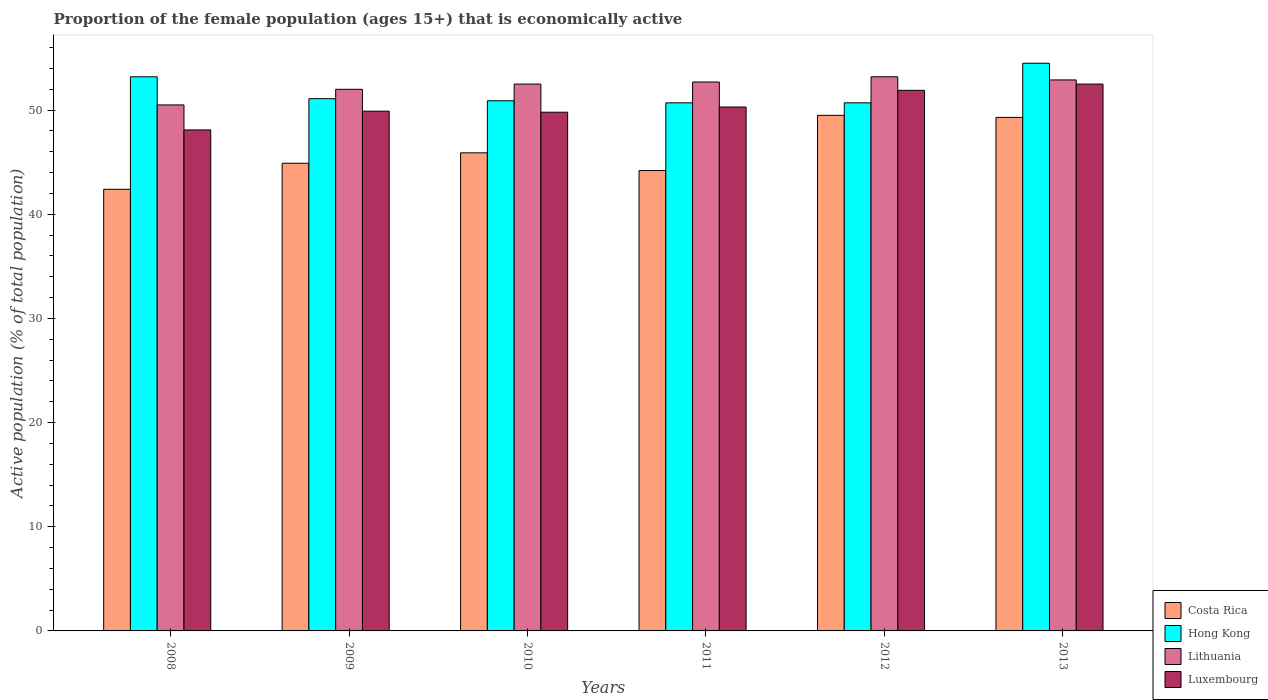How many different coloured bars are there?
Provide a succinct answer. 4. Are the number of bars per tick equal to the number of legend labels?
Your answer should be very brief. Yes. Are the number of bars on each tick of the X-axis equal?
Offer a terse response. Yes. How many bars are there on the 2nd tick from the left?
Your response must be concise. 4. How many bars are there on the 1st tick from the right?
Offer a very short reply. 4. What is the label of the 5th group of bars from the left?
Offer a terse response. 2012. In how many cases, is the number of bars for a given year not equal to the number of legend labels?
Offer a very short reply. 0. What is the proportion of the female population that is economically active in Luxembourg in 2009?
Keep it short and to the point. 49.9. Across all years, what is the maximum proportion of the female population that is economically active in Lithuania?
Provide a succinct answer. 53.2. Across all years, what is the minimum proportion of the female population that is economically active in Costa Rica?
Your answer should be compact. 42.4. In which year was the proportion of the female population that is economically active in Lithuania maximum?
Offer a very short reply. 2012. What is the total proportion of the female population that is economically active in Luxembourg in the graph?
Offer a terse response. 302.5. What is the difference between the proportion of the female population that is economically active in Hong Kong in 2011 and that in 2012?
Give a very brief answer. 0. What is the difference between the proportion of the female population that is economically active in Lithuania in 2009 and the proportion of the female population that is economically active in Hong Kong in 2012?
Your response must be concise. 1.3. What is the average proportion of the female population that is economically active in Costa Rica per year?
Your answer should be very brief. 46.03. In the year 2012, what is the difference between the proportion of the female population that is economically active in Hong Kong and proportion of the female population that is economically active in Costa Rica?
Offer a terse response. 1.2. What is the ratio of the proportion of the female population that is economically active in Luxembourg in 2008 to that in 2009?
Offer a terse response. 0.96. Is the proportion of the female population that is economically active in Luxembourg in 2009 less than that in 2011?
Provide a succinct answer. Yes. What is the difference between the highest and the second highest proportion of the female population that is economically active in Luxembourg?
Give a very brief answer. 0.6. What is the difference between the highest and the lowest proportion of the female population that is economically active in Luxembourg?
Ensure brevity in your answer.  4.4. In how many years, is the proportion of the female population that is economically active in Hong Kong greater than the average proportion of the female population that is economically active in Hong Kong taken over all years?
Keep it short and to the point. 2. Is the sum of the proportion of the female population that is economically active in Costa Rica in 2008 and 2009 greater than the maximum proportion of the female population that is economically active in Lithuania across all years?
Provide a short and direct response. Yes. Is it the case that in every year, the sum of the proportion of the female population that is economically active in Luxembourg and proportion of the female population that is economically active in Hong Kong is greater than the sum of proportion of the female population that is economically active in Costa Rica and proportion of the female population that is economically active in Lithuania?
Keep it short and to the point. Yes. What does the 4th bar from the left in 2011 represents?
Your answer should be compact. Luxembourg. What does the 2nd bar from the right in 2011 represents?
Make the answer very short. Lithuania. Is it the case that in every year, the sum of the proportion of the female population that is economically active in Costa Rica and proportion of the female population that is economically active in Luxembourg is greater than the proportion of the female population that is economically active in Lithuania?
Offer a very short reply. Yes. How many bars are there?
Offer a terse response. 24. Are the values on the major ticks of Y-axis written in scientific E-notation?
Your response must be concise. No. Does the graph contain any zero values?
Your answer should be very brief. No. How many legend labels are there?
Offer a terse response. 4. How are the legend labels stacked?
Your answer should be very brief. Vertical. What is the title of the graph?
Keep it short and to the point. Proportion of the female population (ages 15+) that is economically active. Does "Kyrgyz Republic" appear as one of the legend labels in the graph?
Give a very brief answer. No. What is the label or title of the Y-axis?
Offer a very short reply. Active population (% of total population). What is the Active population (% of total population) in Costa Rica in 2008?
Give a very brief answer. 42.4. What is the Active population (% of total population) in Hong Kong in 2008?
Give a very brief answer. 53.2. What is the Active population (% of total population) in Lithuania in 2008?
Provide a short and direct response. 50.5. What is the Active population (% of total population) in Luxembourg in 2008?
Ensure brevity in your answer.  48.1. What is the Active population (% of total population) of Costa Rica in 2009?
Your answer should be very brief. 44.9. What is the Active population (% of total population) of Hong Kong in 2009?
Provide a short and direct response. 51.1. What is the Active population (% of total population) in Luxembourg in 2009?
Provide a succinct answer. 49.9. What is the Active population (% of total population) in Costa Rica in 2010?
Your answer should be compact. 45.9. What is the Active population (% of total population) of Hong Kong in 2010?
Keep it short and to the point. 50.9. What is the Active population (% of total population) in Lithuania in 2010?
Make the answer very short. 52.5. What is the Active population (% of total population) of Luxembourg in 2010?
Offer a terse response. 49.8. What is the Active population (% of total population) in Costa Rica in 2011?
Provide a short and direct response. 44.2. What is the Active population (% of total population) in Hong Kong in 2011?
Provide a short and direct response. 50.7. What is the Active population (% of total population) in Lithuania in 2011?
Give a very brief answer. 52.7. What is the Active population (% of total population) of Luxembourg in 2011?
Your response must be concise. 50.3. What is the Active population (% of total population) in Costa Rica in 2012?
Make the answer very short. 49.5. What is the Active population (% of total population) in Hong Kong in 2012?
Your answer should be compact. 50.7. What is the Active population (% of total population) of Lithuania in 2012?
Offer a terse response. 53.2. What is the Active population (% of total population) in Luxembourg in 2012?
Your answer should be compact. 51.9. What is the Active population (% of total population) in Costa Rica in 2013?
Give a very brief answer. 49.3. What is the Active population (% of total population) in Hong Kong in 2013?
Give a very brief answer. 54.5. What is the Active population (% of total population) in Lithuania in 2013?
Keep it short and to the point. 52.9. What is the Active population (% of total population) in Luxembourg in 2013?
Provide a short and direct response. 52.5. Across all years, what is the maximum Active population (% of total population) in Costa Rica?
Offer a very short reply. 49.5. Across all years, what is the maximum Active population (% of total population) in Hong Kong?
Provide a short and direct response. 54.5. Across all years, what is the maximum Active population (% of total population) of Lithuania?
Make the answer very short. 53.2. Across all years, what is the maximum Active population (% of total population) in Luxembourg?
Keep it short and to the point. 52.5. Across all years, what is the minimum Active population (% of total population) in Costa Rica?
Make the answer very short. 42.4. Across all years, what is the minimum Active population (% of total population) of Hong Kong?
Your response must be concise. 50.7. Across all years, what is the minimum Active population (% of total population) in Lithuania?
Give a very brief answer. 50.5. Across all years, what is the minimum Active population (% of total population) of Luxembourg?
Offer a very short reply. 48.1. What is the total Active population (% of total population) of Costa Rica in the graph?
Give a very brief answer. 276.2. What is the total Active population (% of total population) of Hong Kong in the graph?
Provide a short and direct response. 311.1. What is the total Active population (% of total population) in Lithuania in the graph?
Make the answer very short. 313.8. What is the total Active population (% of total population) of Luxembourg in the graph?
Keep it short and to the point. 302.5. What is the difference between the Active population (% of total population) of Costa Rica in 2008 and that in 2009?
Your answer should be compact. -2.5. What is the difference between the Active population (% of total population) of Lithuania in 2008 and that in 2010?
Keep it short and to the point. -2. What is the difference between the Active population (% of total population) of Hong Kong in 2008 and that in 2012?
Keep it short and to the point. 2.5. What is the difference between the Active population (% of total population) in Luxembourg in 2008 and that in 2012?
Keep it short and to the point. -3.8. What is the difference between the Active population (% of total population) of Costa Rica in 2008 and that in 2013?
Give a very brief answer. -6.9. What is the difference between the Active population (% of total population) of Hong Kong in 2008 and that in 2013?
Offer a very short reply. -1.3. What is the difference between the Active population (% of total population) in Luxembourg in 2008 and that in 2013?
Your answer should be compact. -4.4. What is the difference between the Active population (% of total population) in Costa Rica in 2009 and that in 2010?
Provide a short and direct response. -1. What is the difference between the Active population (% of total population) of Lithuania in 2009 and that in 2010?
Your response must be concise. -0.5. What is the difference between the Active population (% of total population) of Hong Kong in 2009 and that in 2011?
Give a very brief answer. 0.4. What is the difference between the Active population (% of total population) of Lithuania in 2009 and that in 2011?
Provide a succinct answer. -0.7. What is the difference between the Active population (% of total population) of Luxembourg in 2009 and that in 2011?
Offer a terse response. -0.4. What is the difference between the Active population (% of total population) of Costa Rica in 2009 and that in 2012?
Keep it short and to the point. -4.6. What is the difference between the Active population (% of total population) of Hong Kong in 2009 and that in 2012?
Your response must be concise. 0.4. What is the difference between the Active population (% of total population) in Lithuania in 2009 and that in 2012?
Give a very brief answer. -1.2. What is the difference between the Active population (% of total population) in Luxembourg in 2009 and that in 2012?
Offer a terse response. -2. What is the difference between the Active population (% of total population) of Hong Kong in 2009 and that in 2013?
Give a very brief answer. -3.4. What is the difference between the Active population (% of total population) of Luxembourg in 2009 and that in 2013?
Offer a very short reply. -2.6. What is the difference between the Active population (% of total population) in Costa Rica in 2010 and that in 2011?
Offer a terse response. 1.7. What is the difference between the Active population (% of total population) of Hong Kong in 2010 and that in 2011?
Keep it short and to the point. 0.2. What is the difference between the Active population (% of total population) of Costa Rica in 2010 and that in 2012?
Offer a very short reply. -3.6. What is the difference between the Active population (% of total population) in Lithuania in 2010 and that in 2012?
Provide a short and direct response. -0.7. What is the difference between the Active population (% of total population) of Hong Kong in 2010 and that in 2013?
Provide a short and direct response. -3.6. What is the difference between the Active population (% of total population) of Hong Kong in 2011 and that in 2012?
Make the answer very short. 0. What is the difference between the Active population (% of total population) of Costa Rica in 2011 and that in 2013?
Make the answer very short. -5.1. What is the difference between the Active population (% of total population) in Hong Kong in 2011 and that in 2013?
Your answer should be compact. -3.8. What is the difference between the Active population (% of total population) of Lithuania in 2011 and that in 2013?
Make the answer very short. -0.2. What is the difference between the Active population (% of total population) of Luxembourg in 2011 and that in 2013?
Offer a very short reply. -2.2. What is the difference between the Active population (% of total population) in Lithuania in 2012 and that in 2013?
Provide a succinct answer. 0.3. What is the difference between the Active population (% of total population) of Hong Kong in 2008 and the Active population (% of total population) of Luxembourg in 2009?
Your answer should be compact. 3.3. What is the difference between the Active population (% of total population) of Costa Rica in 2008 and the Active population (% of total population) of Lithuania in 2010?
Your answer should be compact. -10.1. What is the difference between the Active population (% of total population) in Costa Rica in 2008 and the Active population (% of total population) in Luxembourg in 2010?
Offer a terse response. -7.4. What is the difference between the Active population (% of total population) of Hong Kong in 2008 and the Active population (% of total population) of Luxembourg in 2010?
Offer a terse response. 3.4. What is the difference between the Active population (% of total population) of Lithuania in 2008 and the Active population (% of total population) of Luxembourg in 2010?
Offer a very short reply. 0.7. What is the difference between the Active population (% of total population) in Costa Rica in 2008 and the Active population (% of total population) in Hong Kong in 2011?
Keep it short and to the point. -8.3. What is the difference between the Active population (% of total population) of Costa Rica in 2008 and the Active population (% of total population) of Lithuania in 2011?
Offer a very short reply. -10.3. What is the difference between the Active population (% of total population) of Costa Rica in 2008 and the Active population (% of total population) of Luxembourg in 2011?
Give a very brief answer. -7.9. What is the difference between the Active population (% of total population) in Hong Kong in 2008 and the Active population (% of total population) in Lithuania in 2011?
Your answer should be compact. 0.5. What is the difference between the Active population (% of total population) of Hong Kong in 2008 and the Active population (% of total population) of Luxembourg in 2011?
Provide a succinct answer. 2.9. What is the difference between the Active population (% of total population) in Lithuania in 2008 and the Active population (% of total population) in Luxembourg in 2011?
Keep it short and to the point. 0.2. What is the difference between the Active population (% of total population) in Costa Rica in 2008 and the Active population (% of total population) in Lithuania in 2012?
Your answer should be very brief. -10.8. What is the difference between the Active population (% of total population) of Costa Rica in 2008 and the Active population (% of total population) of Luxembourg in 2012?
Make the answer very short. -9.5. What is the difference between the Active population (% of total population) in Hong Kong in 2008 and the Active population (% of total population) in Luxembourg in 2012?
Offer a terse response. 1.3. What is the difference between the Active population (% of total population) in Costa Rica in 2009 and the Active population (% of total population) in Hong Kong in 2010?
Offer a terse response. -6. What is the difference between the Active population (% of total population) of Costa Rica in 2009 and the Active population (% of total population) of Lithuania in 2010?
Offer a very short reply. -7.6. What is the difference between the Active population (% of total population) in Hong Kong in 2009 and the Active population (% of total population) in Lithuania in 2010?
Offer a very short reply. -1.4. What is the difference between the Active population (% of total population) of Lithuania in 2009 and the Active population (% of total population) of Luxembourg in 2010?
Keep it short and to the point. 2.2. What is the difference between the Active population (% of total population) of Costa Rica in 2009 and the Active population (% of total population) of Hong Kong in 2011?
Your response must be concise. -5.8. What is the difference between the Active population (% of total population) of Costa Rica in 2009 and the Active population (% of total population) of Lithuania in 2011?
Give a very brief answer. -7.8. What is the difference between the Active population (% of total population) of Hong Kong in 2009 and the Active population (% of total population) of Lithuania in 2011?
Your answer should be very brief. -1.6. What is the difference between the Active population (% of total population) of Lithuania in 2009 and the Active population (% of total population) of Luxembourg in 2011?
Offer a terse response. 1.7. What is the difference between the Active population (% of total population) of Costa Rica in 2009 and the Active population (% of total population) of Hong Kong in 2012?
Your answer should be compact. -5.8. What is the difference between the Active population (% of total population) of Costa Rica in 2009 and the Active population (% of total population) of Lithuania in 2012?
Offer a very short reply. -8.3. What is the difference between the Active population (% of total population) of Hong Kong in 2009 and the Active population (% of total population) of Lithuania in 2012?
Offer a very short reply. -2.1. What is the difference between the Active population (% of total population) in Hong Kong in 2009 and the Active population (% of total population) in Luxembourg in 2012?
Give a very brief answer. -0.8. What is the difference between the Active population (% of total population) of Lithuania in 2009 and the Active population (% of total population) of Luxembourg in 2012?
Give a very brief answer. 0.1. What is the difference between the Active population (% of total population) of Costa Rica in 2009 and the Active population (% of total population) of Hong Kong in 2013?
Keep it short and to the point. -9.6. What is the difference between the Active population (% of total population) of Costa Rica in 2009 and the Active population (% of total population) of Luxembourg in 2013?
Your answer should be compact. -7.6. What is the difference between the Active population (% of total population) in Hong Kong in 2009 and the Active population (% of total population) in Luxembourg in 2013?
Offer a terse response. -1.4. What is the difference between the Active population (% of total population) in Lithuania in 2009 and the Active population (% of total population) in Luxembourg in 2013?
Your response must be concise. -0.5. What is the difference between the Active population (% of total population) of Costa Rica in 2010 and the Active population (% of total population) of Hong Kong in 2011?
Your response must be concise. -4.8. What is the difference between the Active population (% of total population) of Hong Kong in 2010 and the Active population (% of total population) of Lithuania in 2011?
Give a very brief answer. -1.8. What is the difference between the Active population (% of total population) of Hong Kong in 2010 and the Active population (% of total population) of Luxembourg in 2011?
Your answer should be very brief. 0.6. What is the difference between the Active population (% of total population) of Costa Rica in 2010 and the Active population (% of total population) of Luxembourg in 2012?
Your answer should be compact. -6. What is the difference between the Active population (% of total population) of Lithuania in 2010 and the Active population (% of total population) of Luxembourg in 2012?
Provide a short and direct response. 0.6. What is the difference between the Active population (% of total population) in Costa Rica in 2010 and the Active population (% of total population) in Hong Kong in 2013?
Ensure brevity in your answer.  -8.6. What is the difference between the Active population (% of total population) of Costa Rica in 2011 and the Active population (% of total population) of Luxembourg in 2012?
Your answer should be very brief. -7.7. What is the difference between the Active population (% of total population) in Costa Rica in 2011 and the Active population (% of total population) in Hong Kong in 2013?
Ensure brevity in your answer.  -10.3. What is the difference between the Active population (% of total population) in Lithuania in 2011 and the Active population (% of total population) in Luxembourg in 2013?
Your response must be concise. 0.2. What is the difference between the Active population (% of total population) of Costa Rica in 2012 and the Active population (% of total population) of Lithuania in 2013?
Offer a very short reply. -3.4. What is the difference between the Active population (% of total population) of Hong Kong in 2012 and the Active population (% of total population) of Luxembourg in 2013?
Provide a succinct answer. -1.8. What is the average Active population (% of total population) in Costa Rica per year?
Your answer should be compact. 46.03. What is the average Active population (% of total population) of Hong Kong per year?
Keep it short and to the point. 51.85. What is the average Active population (% of total population) of Lithuania per year?
Keep it short and to the point. 52.3. What is the average Active population (% of total population) in Luxembourg per year?
Make the answer very short. 50.42. In the year 2008, what is the difference between the Active population (% of total population) in Hong Kong and Active population (% of total population) in Luxembourg?
Provide a succinct answer. 5.1. In the year 2008, what is the difference between the Active population (% of total population) in Lithuania and Active population (% of total population) in Luxembourg?
Offer a terse response. 2.4. In the year 2009, what is the difference between the Active population (% of total population) of Costa Rica and Active population (% of total population) of Lithuania?
Your answer should be very brief. -7.1. In the year 2009, what is the difference between the Active population (% of total population) of Costa Rica and Active population (% of total population) of Luxembourg?
Provide a short and direct response. -5. In the year 2009, what is the difference between the Active population (% of total population) in Hong Kong and Active population (% of total population) in Luxembourg?
Make the answer very short. 1.2. In the year 2009, what is the difference between the Active population (% of total population) in Lithuania and Active population (% of total population) in Luxembourg?
Your answer should be compact. 2.1. In the year 2010, what is the difference between the Active population (% of total population) of Costa Rica and Active population (% of total population) of Hong Kong?
Your answer should be compact. -5. In the year 2010, what is the difference between the Active population (% of total population) in Costa Rica and Active population (% of total population) in Luxembourg?
Offer a terse response. -3.9. In the year 2010, what is the difference between the Active population (% of total population) in Hong Kong and Active population (% of total population) in Lithuania?
Your answer should be very brief. -1.6. In the year 2010, what is the difference between the Active population (% of total population) in Hong Kong and Active population (% of total population) in Luxembourg?
Your answer should be compact. 1.1. In the year 2011, what is the difference between the Active population (% of total population) in Costa Rica and Active population (% of total population) in Lithuania?
Make the answer very short. -8.5. In the year 2011, what is the difference between the Active population (% of total population) of Costa Rica and Active population (% of total population) of Luxembourg?
Offer a terse response. -6.1. In the year 2011, what is the difference between the Active population (% of total population) in Hong Kong and Active population (% of total population) in Luxembourg?
Provide a short and direct response. 0.4. In the year 2012, what is the difference between the Active population (% of total population) of Costa Rica and Active population (% of total population) of Hong Kong?
Give a very brief answer. -1.2. In the year 2012, what is the difference between the Active population (% of total population) of Costa Rica and Active population (% of total population) of Lithuania?
Provide a short and direct response. -3.7. In the year 2012, what is the difference between the Active population (% of total population) in Hong Kong and Active population (% of total population) in Luxembourg?
Make the answer very short. -1.2. In the year 2012, what is the difference between the Active population (% of total population) of Lithuania and Active population (% of total population) of Luxembourg?
Offer a terse response. 1.3. In the year 2013, what is the difference between the Active population (% of total population) of Hong Kong and Active population (% of total population) of Lithuania?
Provide a succinct answer. 1.6. In the year 2013, what is the difference between the Active population (% of total population) in Hong Kong and Active population (% of total population) in Luxembourg?
Make the answer very short. 2. In the year 2013, what is the difference between the Active population (% of total population) in Lithuania and Active population (% of total population) in Luxembourg?
Make the answer very short. 0.4. What is the ratio of the Active population (% of total population) of Costa Rica in 2008 to that in 2009?
Your response must be concise. 0.94. What is the ratio of the Active population (% of total population) of Hong Kong in 2008 to that in 2009?
Keep it short and to the point. 1.04. What is the ratio of the Active population (% of total population) of Lithuania in 2008 to that in 2009?
Your answer should be compact. 0.97. What is the ratio of the Active population (% of total population) in Luxembourg in 2008 to that in 2009?
Your response must be concise. 0.96. What is the ratio of the Active population (% of total population) of Costa Rica in 2008 to that in 2010?
Your answer should be very brief. 0.92. What is the ratio of the Active population (% of total population) in Hong Kong in 2008 to that in 2010?
Provide a short and direct response. 1.05. What is the ratio of the Active population (% of total population) of Lithuania in 2008 to that in 2010?
Provide a short and direct response. 0.96. What is the ratio of the Active population (% of total population) of Luxembourg in 2008 to that in 2010?
Give a very brief answer. 0.97. What is the ratio of the Active population (% of total population) of Costa Rica in 2008 to that in 2011?
Your answer should be compact. 0.96. What is the ratio of the Active population (% of total population) of Hong Kong in 2008 to that in 2011?
Keep it short and to the point. 1.05. What is the ratio of the Active population (% of total population) of Lithuania in 2008 to that in 2011?
Provide a short and direct response. 0.96. What is the ratio of the Active population (% of total population) in Luxembourg in 2008 to that in 2011?
Offer a very short reply. 0.96. What is the ratio of the Active population (% of total population) in Costa Rica in 2008 to that in 2012?
Your answer should be compact. 0.86. What is the ratio of the Active population (% of total population) in Hong Kong in 2008 to that in 2012?
Your answer should be compact. 1.05. What is the ratio of the Active population (% of total population) of Lithuania in 2008 to that in 2012?
Ensure brevity in your answer.  0.95. What is the ratio of the Active population (% of total population) of Luxembourg in 2008 to that in 2012?
Provide a succinct answer. 0.93. What is the ratio of the Active population (% of total population) of Costa Rica in 2008 to that in 2013?
Make the answer very short. 0.86. What is the ratio of the Active population (% of total population) of Hong Kong in 2008 to that in 2013?
Ensure brevity in your answer.  0.98. What is the ratio of the Active population (% of total population) in Lithuania in 2008 to that in 2013?
Provide a succinct answer. 0.95. What is the ratio of the Active population (% of total population) in Luxembourg in 2008 to that in 2013?
Ensure brevity in your answer.  0.92. What is the ratio of the Active population (% of total population) in Costa Rica in 2009 to that in 2010?
Offer a very short reply. 0.98. What is the ratio of the Active population (% of total population) of Hong Kong in 2009 to that in 2010?
Offer a terse response. 1. What is the ratio of the Active population (% of total population) of Lithuania in 2009 to that in 2010?
Provide a short and direct response. 0.99. What is the ratio of the Active population (% of total population) of Costa Rica in 2009 to that in 2011?
Provide a short and direct response. 1.02. What is the ratio of the Active population (% of total population) of Hong Kong in 2009 to that in 2011?
Offer a terse response. 1.01. What is the ratio of the Active population (% of total population) in Lithuania in 2009 to that in 2011?
Provide a succinct answer. 0.99. What is the ratio of the Active population (% of total population) of Luxembourg in 2009 to that in 2011?
Offer a very short reply. 0.99. What is the ratio of the Active population (% of total population) of Costa Rica in 2009 to that in 2012?
Your response must be concise. 0.91. What is the ratio of the Active population (% of total population) in Hong Kong in 2009 to that in 2012?
Provide a succinct answer. 1.01. What is the ratio of the Active population (% of total population) of Lithuania in 2009 to that in 2012?
Your answer should be very brief. 0.98. What is the ratio of the Active population (% of total population) in Luxembourg in 2009 to that in 2012?
Provide a succinct answer. 0.96. What is the ratio of the Active population (% of total population) of Costa Rica in 2009 to that in 2013?
Your answer should be very brief. 0.91. What is the ratio of the Active population (% of total population) of Hong Kong in 2009 to that in 2013?
Your response must be concise. 0.94. What is the ratio of the Active population (% of total population) of Luxembourg in 2009 to that in 2013?
Ensure brevity in your answer.  0.95. What is the ratio of the Active population (% of total population) in Costa Rica in 2010 to that in 2011?
Keep it short and to the point. 1.04. What is the ratio of the Active population (% of total population) in Lithuania in 2010 to that in 2011?
Your answer should be very brief. 1. What is the ratio of the Active population (% of total population) of Luxembourg in 2010 to that in 2011?
Give a very brief answer. 0.99. What is the ratio of the Active population (% of total population) of Costa Rica in 2010 to that in 2012?
Offer a very short reply. 0.93. What is the ratio of the Active population (% of total population) in Luxembourg in 2010 to that in 2012?
Offer a very short reply. 0.96. What is the ratio of the Active population (% of total population) of Hong Kong in 2010 to that in 2013?
Make the answer very short. 0.93. What is the ratio of the Active population (% of total population) of Luxembourg in 2010 to that in 2013?
Offer a terse response. 0.95. What is the ratio of the Active population (% of total population) in Costa Rica in 2011 to that in 2012?
Your response must be concise. 0.89. What is the ratio of the Active population (% of total population) in Hong Kong in 2011 to that in 2012?
Ensure brevity in your answer.  1. What is the ratio of the Active population (% of total population) in Lithuania in 2011 to that in 2012?
Offer a very short reply. 0.99. What is the ratio of the Active population (% of total population) of Luxembourg in 2011 to that in 2012?
Offer a very short reply. 0.97. What is the ratio of the Active population (% of total population) of Costa Rica in 2011 to that in 2013?
Your answer should be very brief. 0.9. What is the ratio of the Active population (% of total population) of Hong Kong in 2011 to that in 2013?
Your answer should be compact. 0.93. What is the ratio of the Active population (% of total population) in Lithuania in 2011 to that in 2013?
Offer a terse response. 1. What is the ratio of the Active population (% of total population) in Luxembourg in 2011 to that in 2013?
Your answer should be very brief. 0.96. What is the ratio of the Active population (% of total population) of Costa Rica in 2012 to that in 2013?
Provide a succinct answer. 1. What is the ratio of the Active population (% of total population) of Hong Kong in 2012 to that in 2013?
Ensure brevity in your answer.  0.93. What is the ratio of the Active population (% of total population) of Lithuania in 2012 to that in 2013?
Ensure brevity in your answer.  1.01. What is the ratio of the Active population (% of total population) of Luxembourg in 2012 to that in 2013?
Make the answer very short. 0.99. What is the difference between the highest and the second highest Active population (% of total population) in Luxembourg?
Provide a succinct answer. 0.6. What is the difference between the highest and the lowest Active population (% of total population) of Costa Rica?
Offer a very short reply. 7.1. 